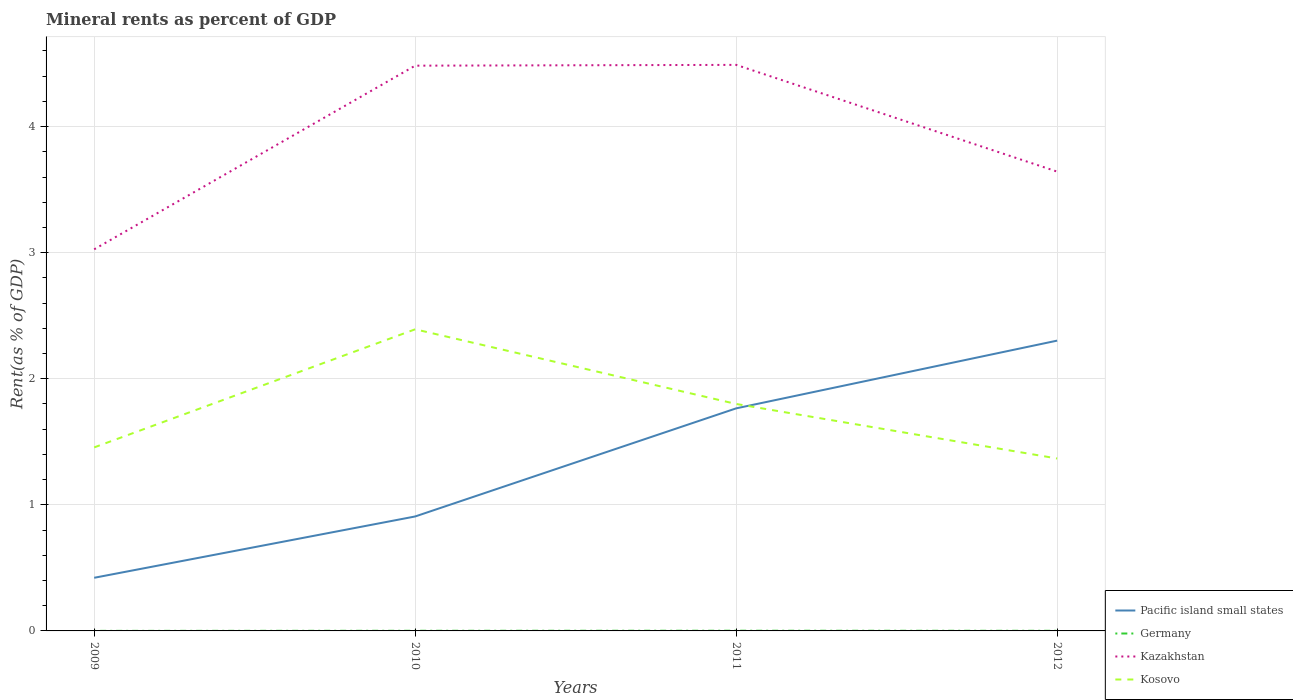Across all years, what is the maximum mineral rent in Germany?
Provide a short and direct response. 0. In which year was the mineral rent in Kosovo maximum?
Your answer should be very brief. 2012. What is the total mineral rent in Kazakhstan in the graph?
Provide a succinct answer. -0.62. What is the difference between the highest and the second highest mineral rent in Kosovo?
Provide a short and direct response. 1.02. What is the difference between the highest and the lowest mineral rent in Germany?
Provide a short and direct response. 2. Is the mineral rent in Pacific island small states strictly greater than the mineral rent in Kazakhstan over the years?
Offer a terse response. Yes. How many years are there in the graph?
Offer a terse response. 4. Are the values on the major ticks of Y-axis written in scientific E-notation?
Offer a terse response. No. Does the graph contain grids?
Give a very brief answer. Yes. How are the legend labels stacked?
Your response must be concise. Vertical. What is the title of the graph?
Provide a succinct answer. Mineral rents as percent of GDP. What is the label or title of the X-axis?
Provide a short and direct response. Years. What is the label or title of the Y-axis?
Your response must be concise. Rent(as % of GDP). What is the Rent(as % of GDP) of Pacific island small states in 2009?
Provide a short and direct response. 0.42. What is the Rent(as % of GDP) in Germany in 2009?
Offer a terse response. 0. What is the Rent(as % of GDP) in Kazakhstan in 2009?
Give a very brief answer. 3.03. What is the Rent(as % of GDP) of Kosovo in 2009?
Ensure brevity in your answer.  1.46. What is the Rent(as % of GDP) in Pacific island small states in 2010?
Your answer should be compact. 0.91. What is the Rent(as % of GDP) of Germany in 2010?
Your response must be concise. 0. What is the Rent(as % of GDP) in Kazakhstan in 2010?
Your response must be concise. 4.48. What is the Rent(as % of GDP) in Kosovo in 2010?
Offer a terse response. 2.39. What is the Rent(as % of GDP) of Pacific island small states in 2011?
Your response must be concise. 1.77. What is the Rent(as % of GDP) in Germany in 2011?
Your response must be concise. 0. What is the Rent(as % of GDP) in Kazakhstan in 2011?
Provide a succinct answer. 4.49. What is the Rent(as % of GDP) in Kosovo in 2011?
Keep it short and to the point. 1.8. What is the Rent(as % of GDP) of Pacific island small states in 2012?
Offer a very short reply. 2.3. What is the Rent(as % of GDP) in Germany in 2012?
Make the answer very short. 0. What is the Rent(as % of GDP) in Kazakhstan in 2012?
Offer a very short reply. 3.64. What is the Rent(as % of GDP) of Kosovo in 2012?
Your answer should be very brief. 1.37. Across all years, what is the maximum Rent(as % of GDP) in Pacific island small states?
Offer a very short reply. 2.3. Across all years, what is the maximum Rent(as % of GDP) of Germany?
Make the answer very short. 0. Across all years, what is the maximum Rent(as % of GDP) in Kazakhstan?
Your response must be concise. 4.49. Across all years, what is the maximum Rent(as % of GDP) in Kosovo?
Your answer should be very brief. 2.39. Across all years, what is the minimum Rent(as % of GDP) of Pacific island small states?
Offer a terse response. 0.42. Across all years, what is the minimum Rent(as % of GDP) of Germany?
Your answer should be compact. 0. Across all years, what is the minimum Rent(as % of GDP) in Kazakhstan?
Your answer should be compact. 3.03. Across all years, what is the minimum Rent(as % of GDP) of Kosovo?
Ensure brevity in your answer.  1.37. What is the total Rent(as % of GDP) in Pacific island small states in the graph?
Provide a succinct answer. 5.4. What is the total Rent(as % of GDP) of Germany in the graph?
Your answer should be compact. 0. What is the total Rent(as % of GDP) of Kazakhstan in the graph?
Your answer should be compact. 15.64. What is the total Rent(as % of GDP) of Kosovo in the graph?
Give a very brief answer. 7.02. What is the difference between the Rent(as % of GDP) of Pacific island small states in 2009 and that in 2010?
Keep it short and to the point. -0.49. What is the difference between the Rent(as % of GDP) in Germany in 2009 and that in 2010?
Keep it short and to the point. -0. What is the difference between the Rent(as % of GDP) of Kazakhstan in 2009 and that in 2010?
Offer a very short reply. -1.46. What is the difference between the Rent(as % of GDP) of Kosovo in 2009 and that in 2010?
Keep it short and to the point. -0.94. What is the difference between the Rent(as % of GDP) in Pacific island small states in 2009 and that in 2011?
Provide a succinct answer. -1.34. What is the difference between the Rent(as % of GDP) in Germany in 2009 and that in 2011?
Provide a succinct answer. -0. What is the difference between the Rent(as % of GDP) of Kazakhstan in 2009 and that in 2011?
Ensure brevity in your answer.  -1.46. What is the difference between the Rent(as % of GDP) in Kosovo in 2009 and that in 2011?
Offer a terse response. -0.34. What is the difference between the Rent(as % of GDP) in Pacific island small states in 2009 and that in 2012?
Provide a short and direct response. -1.88. What is the difference between the Rent(as % of GDP) of Germany in 2009 and that in 2012?
Your answer should be very brief. -0. What is the difference between the Rent(as % of GDP) in Kazakhstan in 2009 and that in 2012?
Provide a short and direct response. -0.62. What is the difference between the Rent(as % of GDP) in Kosovo in 2009 and that in 2012?
Keep it short and to the point. 0.09. What is the difference between the Rent(as % of GDP) of Pacific island small states in 2010 and that in 2011?
Your answer should be compact. -0.86. What is the difference between the Rent(as % of GDP) in Germany in 2010 and that in 2011?
Your answer should be compact. -0. What is the difference between the Rent(as % of GDP) of Kazakhstan in 2010 and that in 2011?
Make the answer very short. -0.01. What is the difference between the Rent(as % of GDP) of Kosovo in 2010 and that in 2011?
Offer a very short reply. 0.59. What is the difference between the Rent(as % of GDP) in Pacific island small states in 2010 and that in 2012?
Offer a terse response. -1.39. What is the difference between the Rent(as % of GDP) in Germany in 2010 and that in 2012?
Your answer should be compact. 0. What is the difference between the Rent(as % of GDP) of Kazakhstan in 2010 and that in 2012?
Your answer should be very brief. 0.84. What is the difference between the Rent(as % of GDP) of Kosovo in 2010 and that in 2012?
Ensure brevity in your answer.  1.02. What is the difference between the Rent(as % of GDP) of Pacific island small states in 2011 and that in 2012?
Provide a short and direct response. -0.54. What is the difference between the Rent(as % of GDP) in Germany in 2011 and that in 2012?
Your response must be concise. 0. What is the difference between the Rent(as % of GDP) of Kazakhstan in 2011 and that in 2012?
Your answer should be compact. 0.85. What is the difference between the Rent(as % of GDP) of Kosovo in 2011 and that in 2012?
Make the answer very short. 0.43. What is the difference between the Rent(as % of GDP) of Pacific island small states in 2009 and the Rent(as % of GDP) of Germany in 2010?
Your response must be concise. 0.42. What is the difference between the Rent(as % of GDP) of Pacific island small states in 2009 and the Rent(as % of GDP) of Kazakhstan in 2010?
Offer a terse response. -4.06. What is the difference between the Rent(as % of GDP) in Pacific island small states in 2009 and the Rent(as % of GDP) in Kosovo in 2010?
Provide a succinct answer. -1.97. What is the difference between the Rent(as % of GDP) in Germany in 2009 and the Rent(as % of GDP) in Kazakhstan in 2010?
Offer a very short reply. -4.48. What is the difference between the Rent(as % of GDP) in Germany in 2009 and the Rent(as % of GDP) in Kosovo in 2010?
Your answer should be compact. -2.39. What is the difference between the Rent(as % of GDP) in Kazakhstan in 2009 and the Rent(as % of GDP) in Kosovo in 2010?
Offer a very short reply. 0.63. What is the difference between the Rent(as % of GDP) in Pacific island small states in 2009 and the Rent(as % of GDP) in Germany in 2011?
Ensure brevity in your answer.  0.42. What is the difference between the Rent(as % of GDP) in Pacific island small states in 2009 and the Rent(as % of GDP) in Kazakhstan in 2011?
Your answer should be very brief. -4.07. What is the difference between the Rent(as % of GDP) in Pacific island small states in 2009 and the Rent(as % of GDP) in Kosovo in 2011?
Give a very brief answer. -1.38. What is the difference between the Rent(as % of GDP) in Germany in 2009 and the Rent(as % of GDP) in Kazakhstan in 2011?
Your answer should be very brief. -4.49. What is the difference between the Rent(as % of GDP) in Germany in 2009 and the Rent(as % of GDP) in Kosovo in 2011?
Provide a succinct answer. -1.8. What is the difference between the Rent(as % of GDP) in Kazakhstan in 2009 and the Rent(as % of GDP) in Kosovo in 2011?
Offer a very short reply. 1.23. What is the difference between the Rent(as % of GDP) of Pacific island small states in 2009 and the Rent(as % of GDP) of Germany in 2012?
Offer a terse response. 0.42. What is the difference between the Rent(as % of GDP) in Pacific island small states in 2009 and the Rent(as % of GDP) in Kazakhstan in 2012?
Your answer should be compact. -3.22. What is the difference between the Rent(as % of GDP) of Pacific island small states in 2009 and the Rent(as % of GDP) of Kosovo in 2012?
Your answer should be very brief. -0.95. What is the difference between the Rent(as % of GDP) of Germany in 2009 and the Rent(as % of GDP) of Kazakhstan in 2012?
Keep it short and to the point. -3.64. What is the difference between the Rent(as % of GDP) of Germany in 2009 and the Rent(as % of GDP) of Kosovo in 2012?
Provide a short and direct response. -1.37. What is the difference between the Rent(as % of GDP) of Kazakhstan in 2009 and the Rent(as % of GDP) of Kosovo in 2012?
Your answer should be compact. 1.66. What is the difference between the Rent(as % of GDP) in Pacific island small states in 2010 and the Rent(as % of GDP) in Germany in 2011?
Offer a terse response. 0.91. What is the difference between the Rent(as % of GDP) in Pacific island small states in 2010 and the Rent(as % of GDP) in Kazakhstan in 2011?
Ensure brevity in your answer.  -3.58. What is the difference between the Rent(as % of GDP) in Pacific island small states in 2010 and the Rent(as % of GDP) in Kosovo in 2011?
Your response must be concise. -0.89. What is the difference between the Rent(as % of GDP) in Germany in 2010 and the Rent(as % of GDP) in Kazakhstan in 2011?
Offer a very short reply. -4.49. What is the difference between the Rent(as % of GDP) in Germany in 2010 and the Rent(as % of GDP) in Kosovo in 2011?
Your response must be concise. -1.8. What is the difference between the Rent(as % of GDP) in Kazakhstan in 2010 and the Rent(as % of GDP) in Kosovo in 2011?
Provide a short and direct response. 2.68. What is the difference between the Rent(as % of GDP) in Pacific island small states in 2010 and the Rent(as % of GDP) in Germany in 2012?
Keep it short and to the point. 0.91. What is the difference between the Rent(as % of GDP) in Pacific island small states in 2010 and the Rent(as % of GDP) in Kazakhstan in 2012?
Provide a succinct answer. -2.73. What is the difference between the Rent(as % of GDP) in Pacific island small states in 2010 and the Rent(as % of GDP) in Kosovo in 2012?
Make the answer very short. -0.46. What is the difference between the Rent(as % of GDP) of Germany in 2010 and the Rent(as % of GDP) of Kazakhstan in 2012?
Make the answer very short. -3.64. What is the difference between the Rent(as % of GDP) of Germany in 2010 and the Rent(as % of GDP) of Kosovo in 2012?
Keep it short and to the point. -1.37. What is the difference between the Rent(as % of GDP) in Kazakhstan in 2010 and the Rent(as % of GDP) in Kosovo in 2012?
Your response must be concise. 3.12. What is the difference between the Rent(as % of GDP) in Pacific island small states in 2011 and the Rent(as % of GDP) in Germany in 2012?
Make the answer very short. 1.76. What is the difference between the Rent(as % of GDP) in Pacific island small states in 2011 and the Rent(as % of GDP) in Kazakhstan in 2012?
Offer a very short reply. -1.88. What is the difference between the Rent(as % of GDP) of Pacific island small states in 2011 and the Rent(as % of GDP) of Kosovo in 2012?
Your answer should be very brief. 0.4. What is the difference between the Rent(as % of GDP) of Germany in 2011 and the Rent(as % of GDP) of Kazakhstan in 2012?
Offer a terse response. -3.64. What is the difference between the Rent(as % of GDP) in Germany in 2011 and the Rent(as % of GDP) in Kosovo in 2012?
Ensure brevity in your answer.  -1.37. What is the difference between the Rent(as % of GDP) in Kazakhstan in 2011 and the Rent(as % of GDP) in Kosovo in 2012?
Make the answer very short. 3.12. What is the average Rent(as % of GDP) of Pacific island small states per year?
Provide a short and direct response. 1.35. What is the average Rent(as % of GDP) of Germany per year?
Give a very brief answer. 0. What is the average Rent(as % of GDP) of Kazakhstan per year?
Make the answer very short. 3.91. What is the average Rent(as % of GDP) of Kosovo per year?
Offer a terse response. 1.75. In the year 2009, what is the difference between the Rent(as % of GDP) of Pacific island small states and Rent(as % of GDP) of Germany?
Ensure brevity in your answer.  0.42. In the year 2009, what is the difference between the Rent(as % of GDP) of Pacific island small states and Rent(as % of GDP) of Kazakhstan?
Ensure brevity in your answer.  -2.61. In the year 2009, what is the difference between the Rent(as % of GDP) of Pacific island small states and Rent(as % of GDP) of Kosovo?
Ensure brevity in your answer.  -1.03. In the year 2009, what is the difference between the Rent(as % of GDP) in Germany and Rent(as % of GDP) in Kazakhstan?
Your answer should be compact. -3.03. In the year 2009, what is the difference between the Rent(as % of GDP) in Germany and Rent(as % of GDP) in Kosovo?
Offer a terse response. -1.46. In the year 2009, what is the difference between the Rent(as % of GDP) in Kazakhstan and Rent(as % of GDP) in Kosovo?
Offer a terse response. 1.57. In the year 2010, what is the difference between the Rent(as % of GDP) in Pacific island small states and Rent(as % of GDP) in Germany?
Provide a short and direct response. 0.91. In the year 2010, what is the difference between the Rent(as % of GDP) of Pacific island small states and Rent(as % of GDP) of Kazakhstan?
Your response must be concise. -3.58. In the year 2010, what is the difference between the Rent(as % of GDP) of Pacific island small states and Rent(as % of GDP) of Kosovo?
Provide a succinct answer. -1.48. In the year 2010, what is the difference between the Rent(as % of GDP) of Germany and Rent(as % of GDP) of Kazakhstan?
Keep it short and to the point. -4.48. In the year 2010, what is the difference between the Rent(as % of GDP) in Germany and Rent(as % of GDP) in Kosovo?
Make the answer very short. -2.39. In the year 2010, what is the difference between the Rent(as % of GDP) in Kazakhstan and Rent(as % of GDP) in Kosovo?
Provide a short and direct response. 2.09. In the year 2011, what is the difference between the Rent(as % of GDP) of Pacific island small states and Rent(as % of GDP) of Germany?
Provide a short and direct response. 1.76. In the year 2011, what is the difference between the Rent(as % of GDP) in Pacific island small states and Rent(as % of GDP) in Kazakhstan?
Give a very brief answer. -2.72. In the year 2011, what is the difference between the Rent(as % of GDP) in Pacific island small states and Rent(as % of GDP) in Kosovo?
Ensure brevity in your answer.  -0.03. In the year 2011, what is the difference between the Rent(as % of GDP) of Germany and Rent(as % of GDP) of Kazakhstan?
Offer a terse response. -4.49. In the year 2011, what is the difference between the Rent(as % of GDP) of Germany and Rent(as % of GDP) of Kosovo?
Make the answer very short. -1.8. In the year 2011, what is the difference between the Rent(as % of GDP) of Kazakhstan and Rent(as % of GDP) of Kosovo?
Keep it short and to the point. 2.69. In the year 2012, what is the difference between the Rent(as % of GDP) of Pacific island small states and Rent(as % of GDP) of Germany?
Your answer should be very brief. 2.3. In the year 2012, what is the difference between the Rent(as % of GDP) of Pacific island small states and Rent(as % of GDP) of Kazakhstan?
Offer a terse response. -1.34. In the year 2012, what is the difference between the Rent(as % of GDP) in Pacific island small states and Rent(as % of GDP) in Kosovo?
Offer a terse response. 0.94. In the year 2012, what is the difference between the Rent(as % of GDP) of Germany and Rent(as % of GDP) of Kazakhstan?
Your response must be concise. -3.64. In the year 2012, what is the difference between the Rent(as % of GDP) in Germany and Rent(as % of GDP) in Kosovo?
Your answer should be compact. -1.37. In the year 2012, what is the difference between the Rent(as % of GDP) in Kazakhstan and Rent(as % of GDP) in Kosovo?
Offer a terse response. 2.28. What is the ratio of the Rent(as % of GDP) in Pacific island small states in 2009 to that in 2010?
Offer a terse response. 0.46. What is the ratio of the Rent(as % of GDP) in Germany in 2009 to that in 2010?
Give a very brief answer. 0.34. What is the ratio of the Rent(as % of GDP) of Kazakhstan in 2009 to that in 2010?
Make the answer very short. 0.68. What is the ratio of the Rent(as % of GDP) of Kosovo in 2009 to that in 2010?
Your answer should be compact. 0.61. What is the ratio of the Rent(as % of GDP) in Pacific island small states in 2009 to that in 2011?
Provide a short and direct response. 0.24. What is the ratio of the Rent(as % of GDP) of Germany in 2009 to that in 2011?
Offer a terse response. 0.26. What is the ratio of the Rent(as % of GDP) in Kazakhstan in 2009 to that in 2011?
Your response must be concise. 0.67. What is the ratio of the Rent(as % of GDP) in Kosovo in 2009 to that in 2011?
Make the answer very short. 0.81. What is the ratio of the Rent(as % of GDP) in Pacific island small states in 2009 to that in 2012?
Your answer should be compact. 0.18. What is the ratio of the Rent(as % of GDP) of Germany in 2009 to that in 2012?
Give a very brief answer. 0.39. What is the ratio of the Rent(as % of GDP) of Kazakhstan in 2009 to that in 2012?
Your answer should be very brief. 0.83. What is the ratio of the Rent(as % of GDP) of Kosovo in 2009 to that in 2012?
Offer a very short reply. 1.06. What is the ratio of the Rent(as % of GDP) in Pacific island small states in 2010 to that in 2011?
Offer a terse response. 0.51. What is the ratio of the Rent(as % of GDP) of Germany in 2010 to that in 2011?
Your answer should be compact. 0.75. What is the ratio of the Rent(as % of GDP) of Kosovo in 2010 to that in 2011?
Provide a short and direct response. 1.33. What is the ratio of the Rent(as % of GDP) in Pacific island small states in 2010 to that in 2012?
Your response must be concise. 0.39. What is the ratio of the Rent(as % of GDP) in Germany in 2010 to that in 2012?
Your answer should be compact. 1.13. What is the ratio of the Rent(as % of GDP) in Kazakhstan in 2010 to that in 2012?
Provide a succinct answer. 1.23. What is the ratio of the Rent(as % of GDP) of Kosovo in 2010 to that in 2012?
Your answer should be compact. 1.75. What is the ratio of the Rent(as % of GDP) in Pacific island small states in 2011 to that in 2012?
Your answer should be very brief. 0.77. What is the ratio of the Rent(as % of GDP) in Germany in 2011 to that in 2012?
Make the answer very short. 1.51. What is the ratio of the Rent(as % of GDP) in Kazakhstan in 2011 to that in 2012?
Give a very brief answer. 1.23. What is the ratio of the Rent(as % of GDP) in Kosovo in 2011 to that in 2012?
Offer a very short reply. 1.32. What is the difference between the highest and the second highest Rent(as % of GDP) in Pacific island small states?
Give a very brief answer. 0.54. What is the difference between the highest and the second highest Rent(as % of GDP) of Germany?
Keep it short and to the point. 0. What is the difference between the highest and the second highest Rent(as % of GDP) in Kazakhstan?
Offer a very short reply. 0.01. What is the difference between the highest and the second highest Rent(as % of GDP) of Kosovo?
Offer a very short reply. 0.59. What is the difference between the highest and the lowest Rent(as % of GDP) in Pacific island small states?
Your answer should be very brief. 1.88. What is the difference between the highest and the lowest Rent(as % of GDP) of Germany?
Your answer should be compact. 0. What is the difference between the highest and the lowest Rent(as % of GDP) of Kazakhstan?
Make the answer very short. 1.46. What is the difference between the highest and the lowest Rent(as % of GDP) of Kosovo?
Provide a short and direct response. 1.02. 